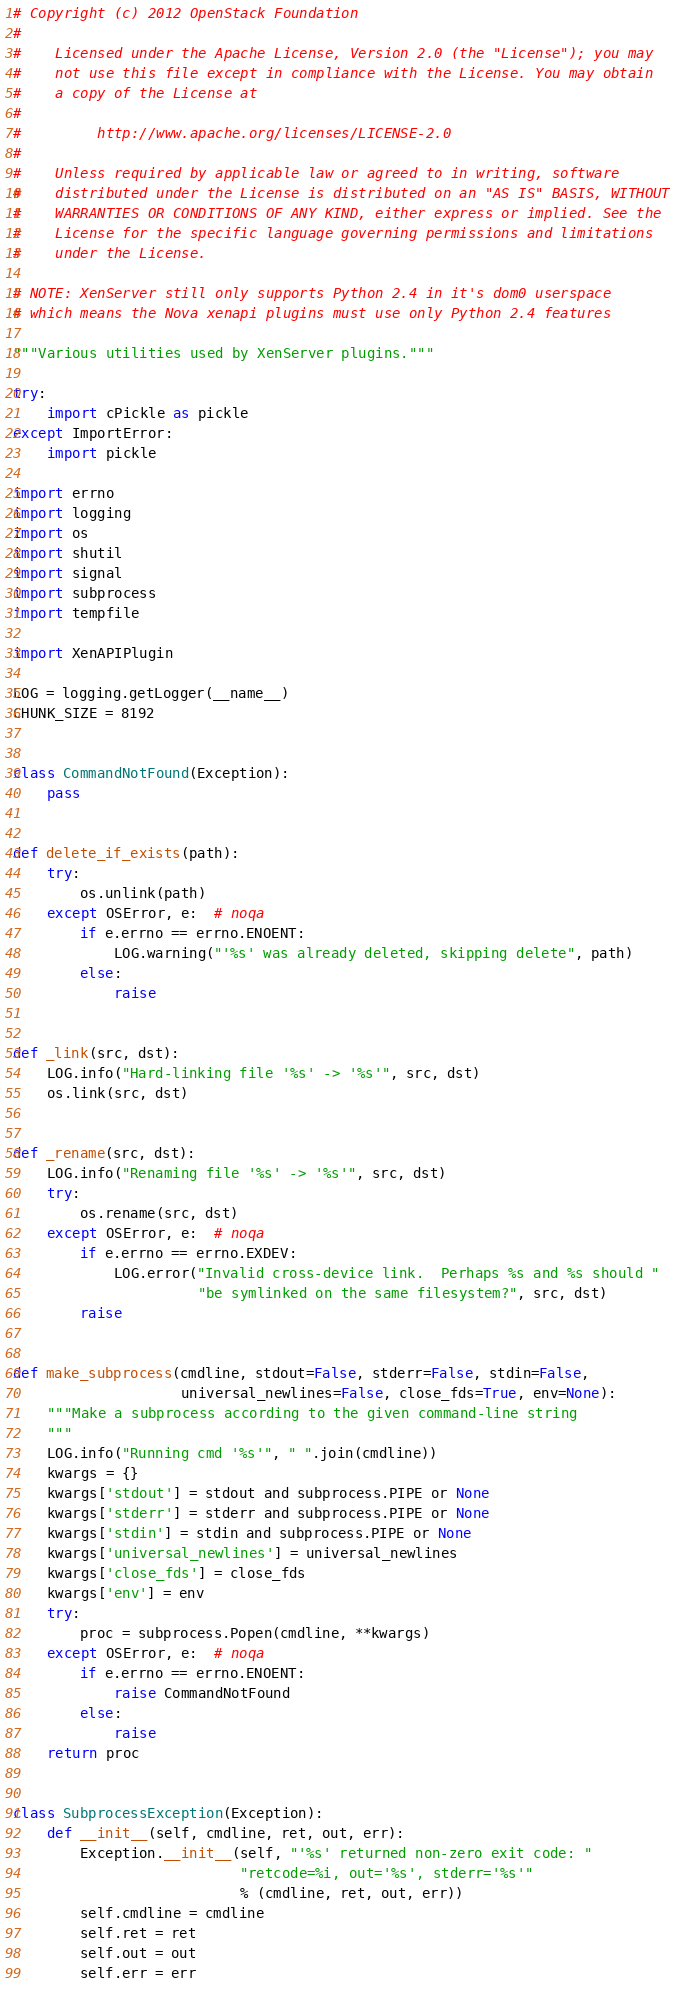<code> <loc_0><loc_0><loc_500><loc_500><_Python_># Copyright (c) 2012 OpenStack Foundation
#
#    Licensed under the Apache License, Version 2.0 (the "License"); you may
#    not use this file except in compliance with the License. You may obtain
#    a copy of the License at
#
#         http://www.apache.org/licenses/LICENSE-2.0
#
#    Unless required by applicable law or agreed to in writing, software
#    distributed under the License is distributed on an "AS IS" BASIS, WITHOUT
#    WARRANTIES OR CONDITIONS OF ANY KIND, either express or implied. See the
#    License for the specific language governing permissions and limitations
#    under the License.

# NOTE: XenServer still only supports Python 2.4 in it's dom0 userspace
# which means the Nova xenapi plugins must use only Python 2.4 features

"""Various utilities used by XenServer plugins."""

try:
    import cPickle as pickle
except ImportError:
    import pickle

import errno
import logging
import os
import shutil
import signal
import subprocess
import tempfile

import XenAPIPlugin

LOG = logging.getLogger(__name__)
CHUNK_SIZE = 8192


class CommandNotFound(Exception):
    pass


def delete_if_exists(path):
    try:
        os.unlink(path)
    except OSError, e:  # noqa
        if e.errno == errno.ENOENT:
            LOG.warning("'%s' was already deleted, skipping delete", path)
        else:
            raise


def _link(src, dst):
    LOG.info("Hard-linking file '%s' -> '%s'", src, dst)
    os.link(src, dst)


def _rename(src, dst):
    LOG.info("Renaming file '%s' -> '%s'", src, dst)
    try:
        os.rename(src, dst)
    except OSError, e:  # noqa
        if e.errno == errno.EXDEV:
            LOG.error("Invalid cross-device link.  Perhaps %s and %s should "
                      "be symlinked on the same filesystem?", src, dst)
        raise


def make_subprocess(cmdline, stdout=False, stderr=False, stdin=False,
                    universal_newlines=False, close_fds=True, env=None):
    """Make a subprocess according to the given command-line string
    """
    LOG.info("Running cmd '%s'", " ".join(cmdline))
    kwargs = {}
    kwargs['stdout'] = stdout and subprocess.PIPE or None
    kwargs['stderr'] = stderr and subprocess.PIPE or None
    kwargs['stdin'] = stdin and subprocess.PIPE or None
    kwargs['universal_newlines'] = universal_newlines
    kwargs['close_fds'] = close_fds
    kwargs['env'] = env
    try:
        proc = subprocess.Popen(cmdline, **kwargs)
    except OSError, e:  # noqa
        if e.errno == errno.ENOENT:
            raise CommandNotFound
        else:
            raise
    return proc


class SubprocessException(Exception):
    def __init__(self, cmdline, ret, out, err):
        Exception.__init__(self, "'%s' returned non-zero exit code: "
                           "retcode=%i, out='%s', stderr='%s'"
                           % (cmdline, ret, out, err))
        self.cmdline = cmdline
        self.ret = ret
        self.out = out
        self.err = err

</code> 